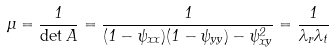<formula> <loc_0><loc_0><loc_500><loc_500>\mu = \frac { 1 } { \det { A } } = \frac { 1 } { ( 1 - \psi _ { x x } ) ( 1 - \psi _ { y y } ) - \psi _ { x y } ^ { 2 } } = \frac { 1 } { \lambda _ { r } \lambda _ { t } }</formula> 